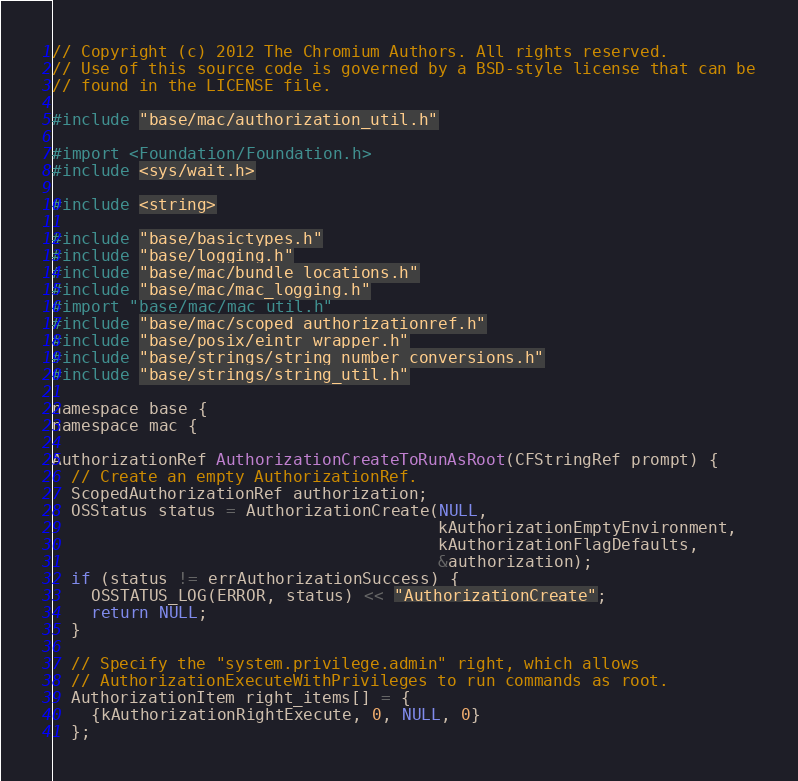<code> <loc_0><loc_0><loc_500><loc_500><_ObjectiveC_>// Copyright (c) 2012 The Chromium Authors. All rights reserved.
// Use of this source code is governed by a BSD-style license that can be
// found in the LICENSE file.

#include "base/mac/authorization_util.h"

#import <Foundation/Foundation.h>
#include <sys/wait.h>

#include <string>

#include "base/basictypes.h"
#include "base/logging.h"
#include "base/mac/bundle_locations.h"
#include "base/mac/mac_logging.h"
#import "base/mac/mac_util.h"
#include "base/mac/scoped_authorizationref.h"
#include "base/posix/eintr_wrapper.h"
#include "base/strings/string_number_conversions.h"
#include "base/strings/string_util.h"

namespace base {
namespace mac {

AuthorizationRef AuthorizationCreateToRunAsRoot(CFStringRef prompt) {
  // Create an empty AuthorizationRef.
  ScopedAuthorizationRef authorization;
  OSStatus status = AuthorizationCreate(NULL,
                                        kAuthorizationEmptyEnvironment,
                                        kAuthorizationFlagDefaults,
                                        &authorization);
  if (status != errAuthorizationSuccess) {
    OSSTATUS_LOG(ERROR, status) << "AuthorizationCreate";
    return NULL;
  }

  // Specify the "system.privilege.admin" right, which allows
  // AuthorizationExecuteWithPrivileges to run commands as root.
  AuthorizationItem right_items[] = {
    {kAuthorizationRightExecute, 0, NULL, 0}
  };</code> 